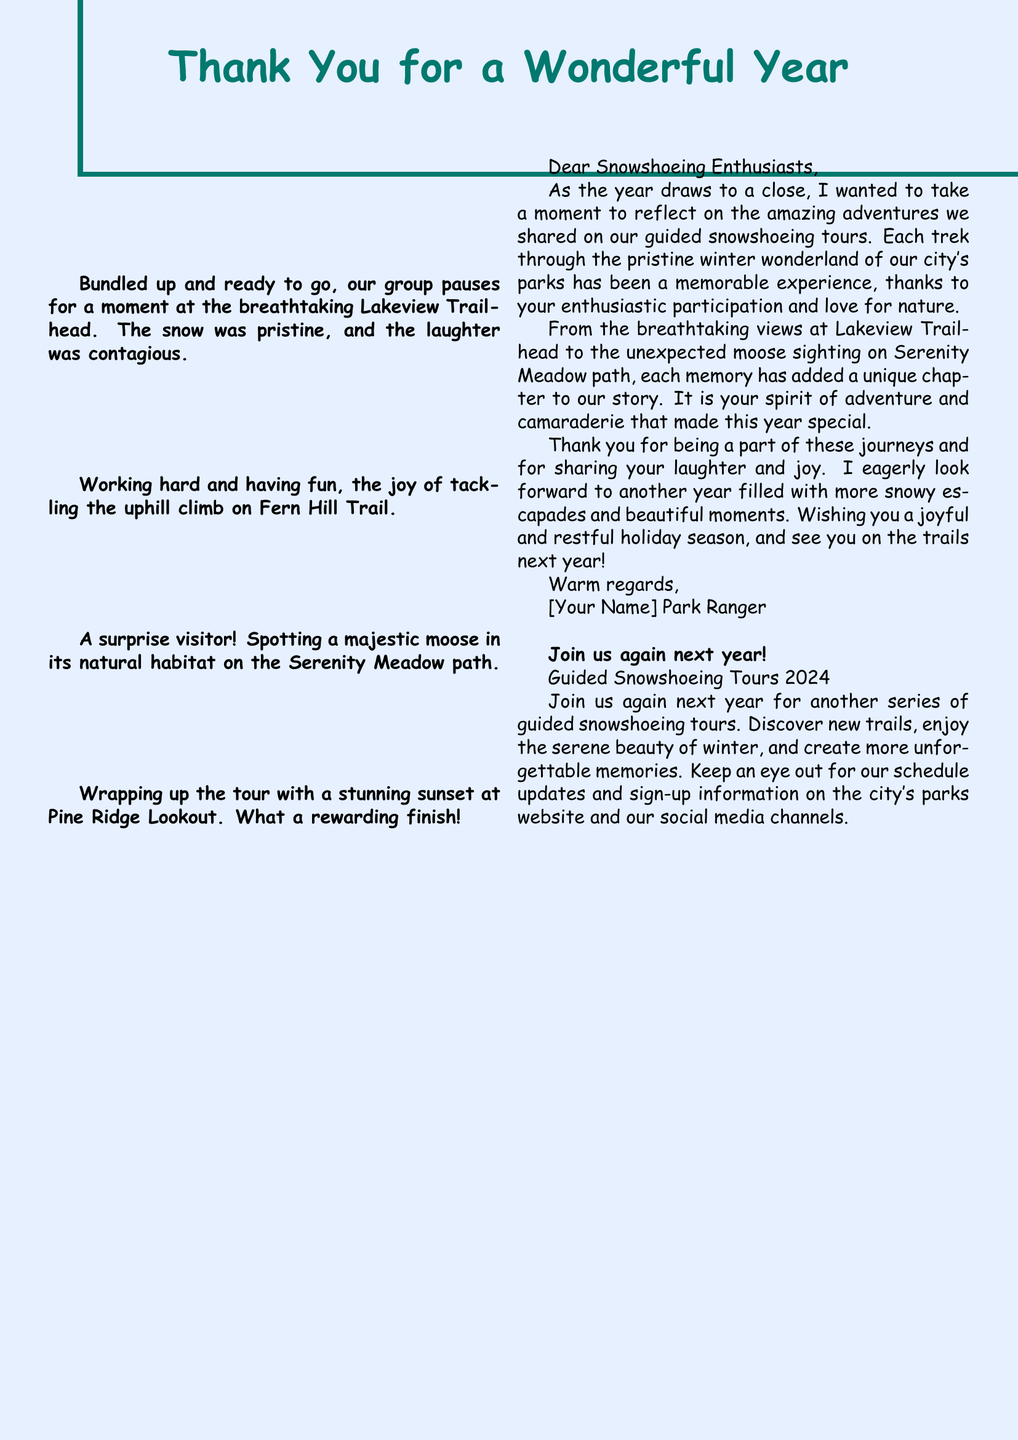What is the title of the card? The title of the card is prominently displayed at the top of the document.
Answer: Thank You for a Wonderful Year How many memorable moments are listed? The document lists four specific memorable moments from the tours.
Answer: 4 Which trail had a stunning sunset? The document mentions the location of a stunning sunset during a tour.
Answer: Pine Ridge Lookout Who is the author of the personal note? The author is identified in the closing section of the note.
Answer: [Your Name] What type of tours does the card promote for next year? The document clearly states the focus of future events.
Answer: Guided Snowshoeing Tours What natural animal was spotted during the tours? The document includes a specific mention of a wildlife encounter.
Answer: Moose What color is used for the main text? The document specifies the color used for the main title.
Answer: Pine green What sentiment is expressed towards the participants? The personal note conveys a particular feeling about the participants' involvement.
Answer: Gratitude 